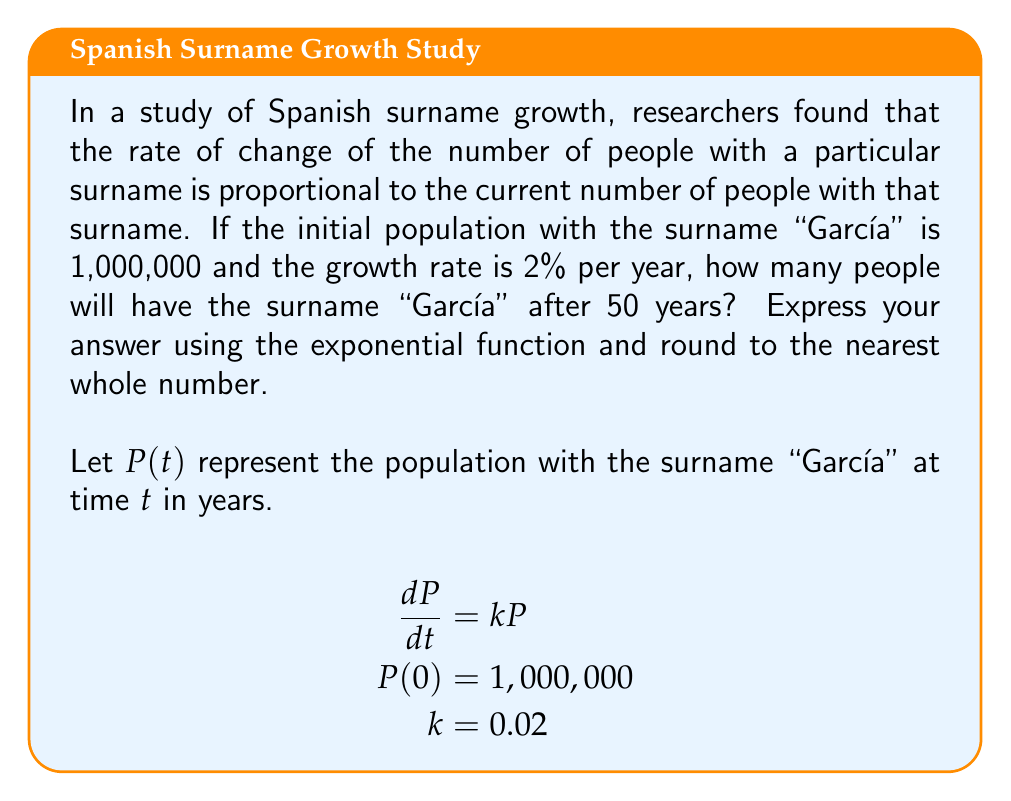Can you answer this question? To solve this first-order differential equation:

1) The general solution for $\frac{dP}{dt} = kP$ is:
   $$P(t) = Ce^{kt}$$
   where $C$ is a constant.

2) Use the initial condition to find $C$:
   $$P(0) = Ce^{k(0)} = C = 1,000,000$$

3) Substitute the values:
   $$P(t) = 1,000,000e^{0.02t}$$

4) To find the population after 50 years, evaluate $P(50)$:
   $$P(50) = 1,000,000e^{0.02(50)}$$
   $$P(50) = 1,000,000e^{1}$$
   $$P(50) = 1,000,000 \cdot 2.71828...$$
   $$P(50) \approx 2,718,282$$

5) Rounding to the nearest whole number:
   $$P(50) \approx 2,718,282$$
Answer: $P(50) = 1,000,000e^{1} \approx 2,718,282$ 